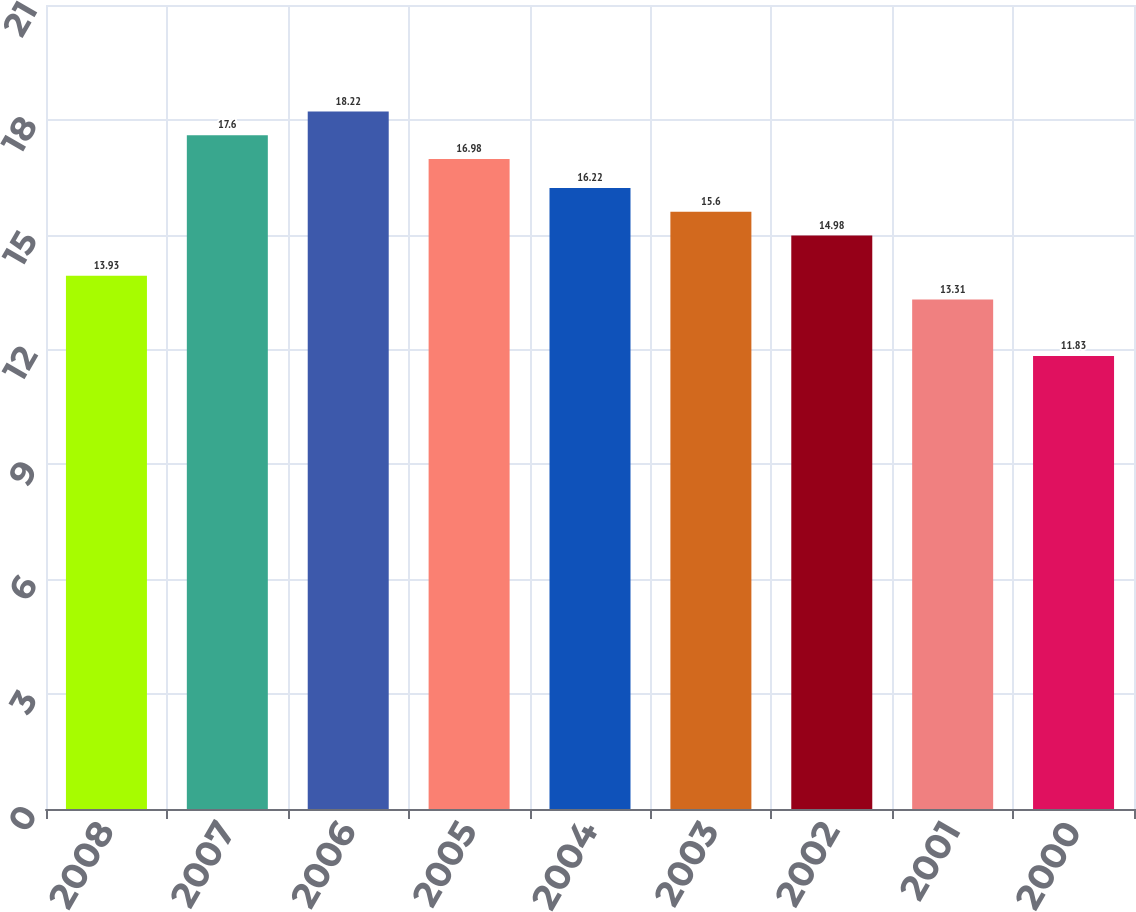Convert chart to OTSL. <chart><loc_0><loc_0><loc_500><loc_500><bar_chart><fcel>2008<fcel>2007<fcel>2006<fcel>2005<fcel>2004<fcel>2003<fcel>2002<fcel>2001<fcel>2000<nl><fcel>13.93<fcel>17.6<fcel>18.22<fcel>16.98<fcel>16.22<fcel>15.6<fcel>14.98<fcel>13.31<fcel>11.83<nl></chart> 